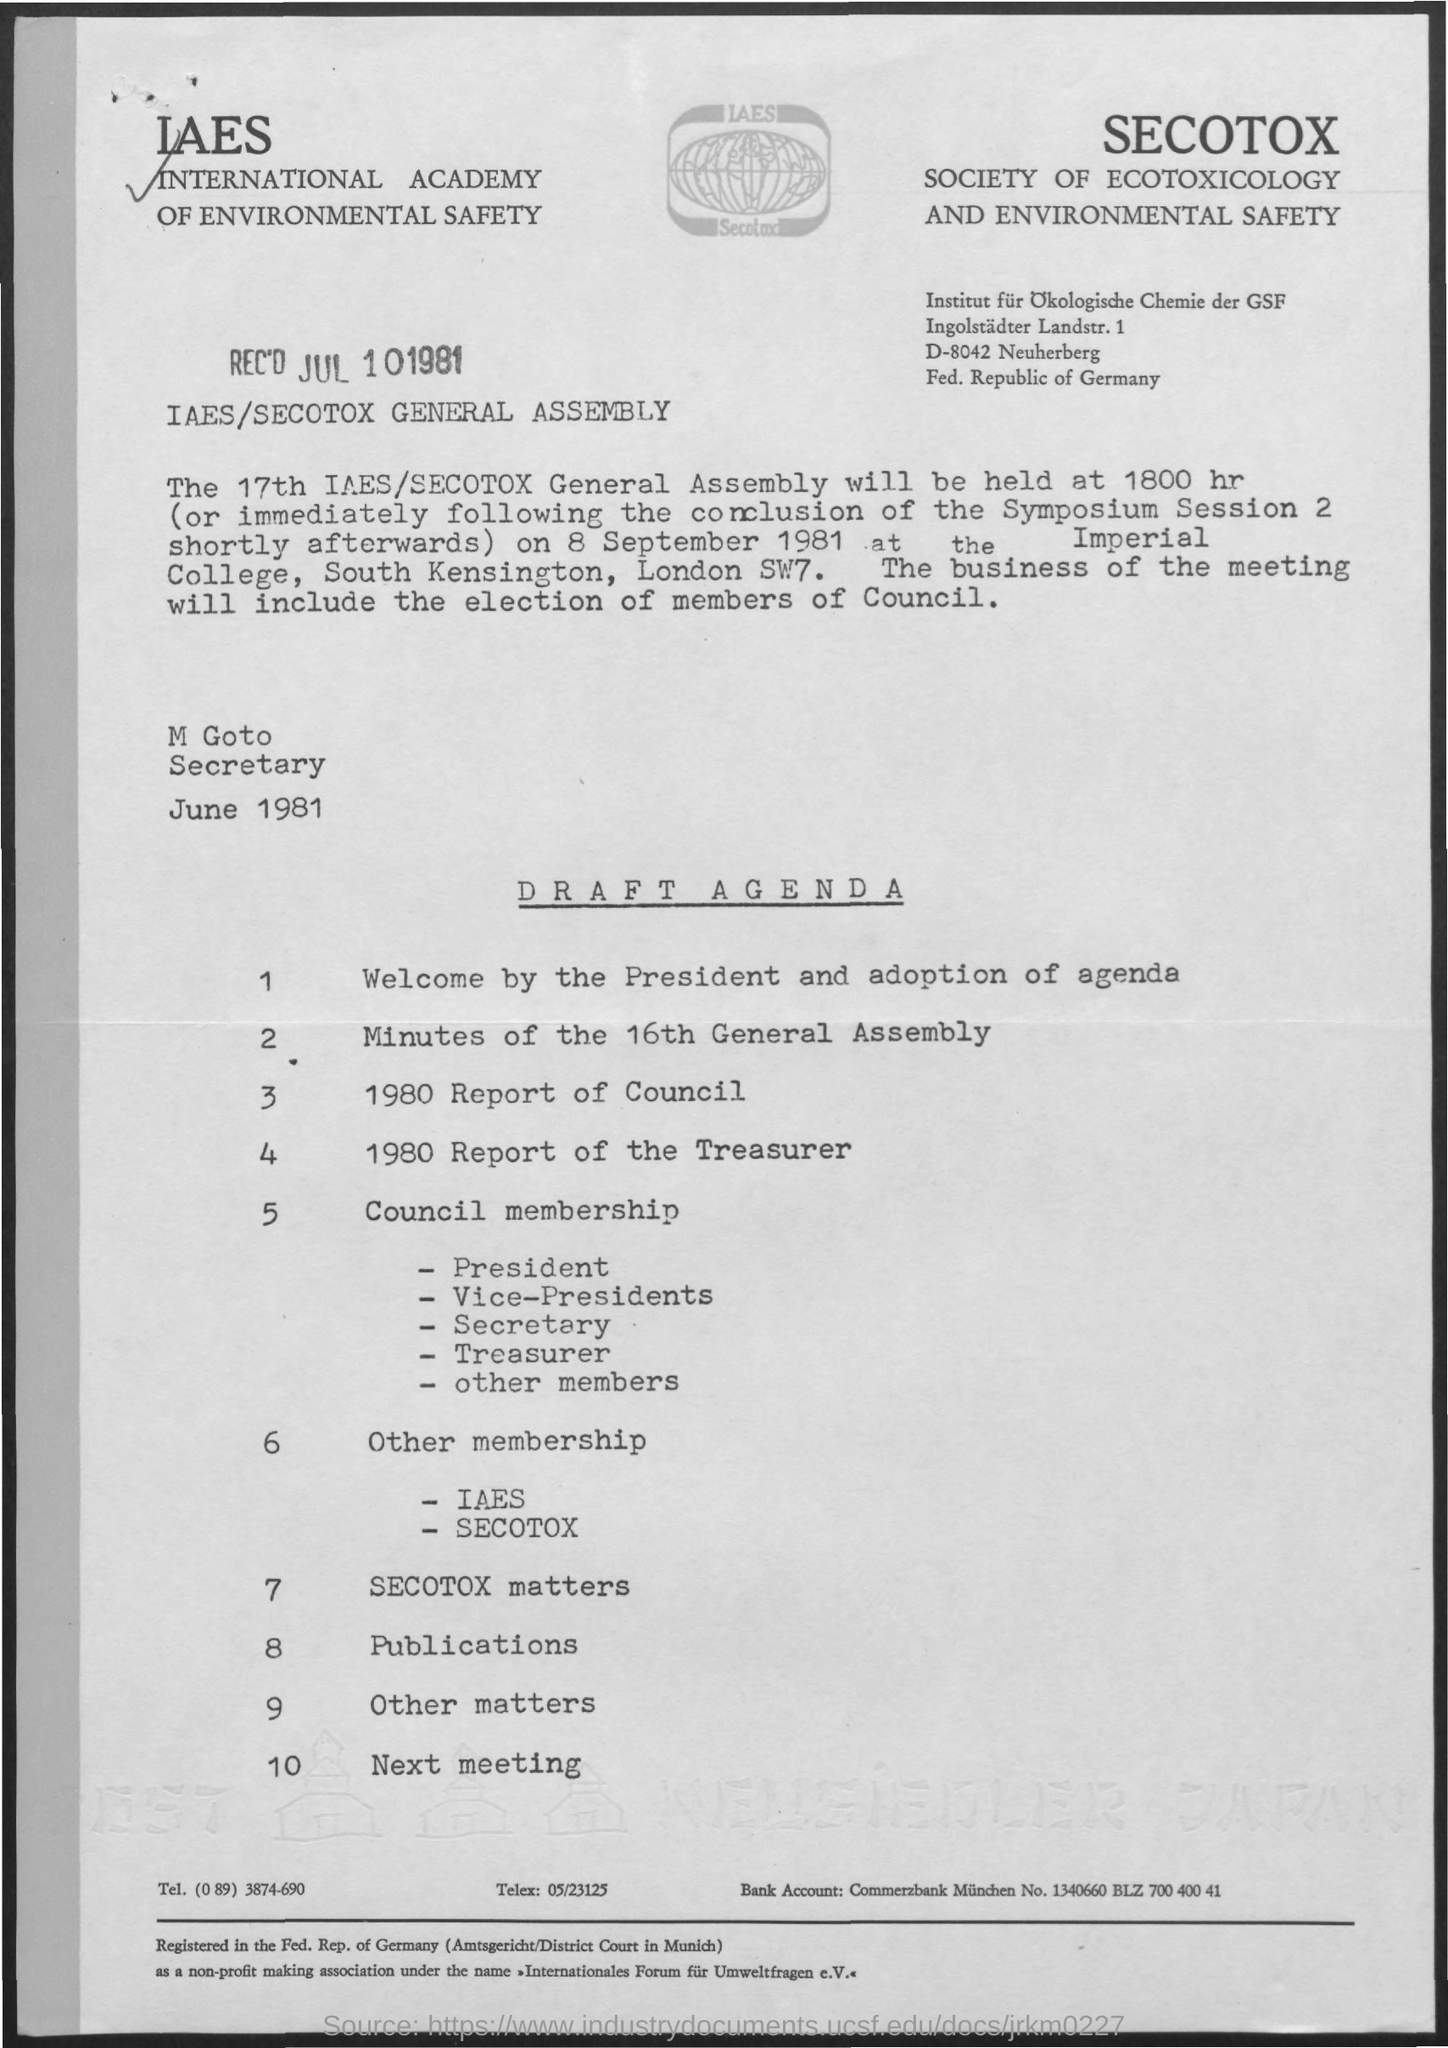Specify some key components in this picture. The date of the general assembly is Thursday, September 8th, 1981. There are nine agenda items related to "Other Matters. There is one agenda in the agenda notice with 10 items. What is the 3rd Agenda? The 1980 report of the council provides insight into the details of this topic. 